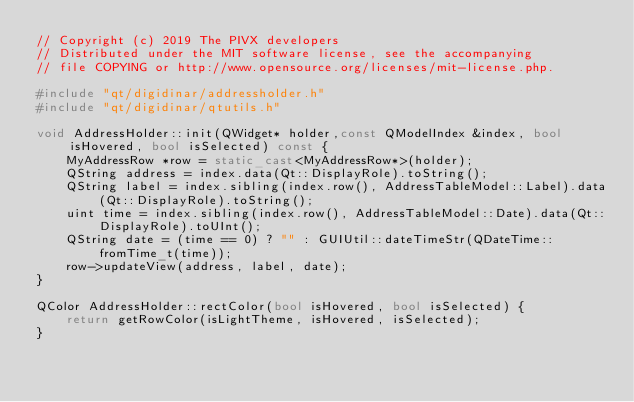Convert code to text. <code><loc_0><loc_0><loc_500><loc_500><_C++_>// Copyright (c) 2019 The PIVX developers
// Distributed under the MIT software license, see the accompanying
// file COPYING or http://www.opensource.org/licenses/mit-license.php.

#include "qt/digidinar/addressholder.h"
#include "qt/digidinar/qtutils.h"

void AddressHolder::init(QWidget* holder,const QModelIndex &index, bool isHovered, bool isSelected) const {
    MyAddressRow *row = static_cast<MyAddressRow*>(holder);
    QString address = index.data(Qt::DisplayRole).toString();
    QString label = index.sibling(index.row(), AddressTableModel::Label).data(Qt::DisplayRole).toString();
    uint time = index.sibling(index.row(), AddressTableModel::Date).data(Qt::DisplayRole).toUInt();
    QString date = (time == 0) ? "" : GUIUtil::dateTimeStr(QDateTime::fromTime_t(time));
    row->updateView(address, label, date);
}

QColor AddressHolder::rectColor(bool isHovered, bool isSelected) {
    return getRowColor(isLightTheme, isHovered, isSelected);
}
</code> 